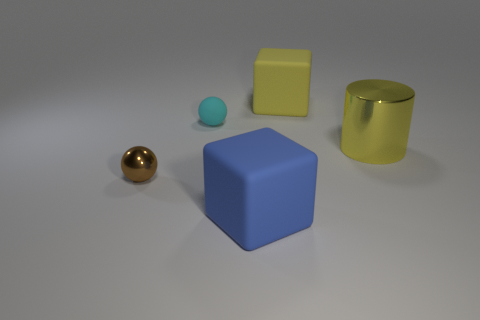Add 5 yellow cylinders. How many objects exist? 10 Subtract all blocks. How many objects are left? 3 Add 1 purple cubes. How many purple cubes exist? 1 Subtract 0 gray cylinders. How many objects are left? 5 Subtract all big purple metal things. Subtract all tiny cyan matte things. How many objects are left? 4 Add 3 small cyan matte spheres. How many small cyan matte spheres are left? 4 